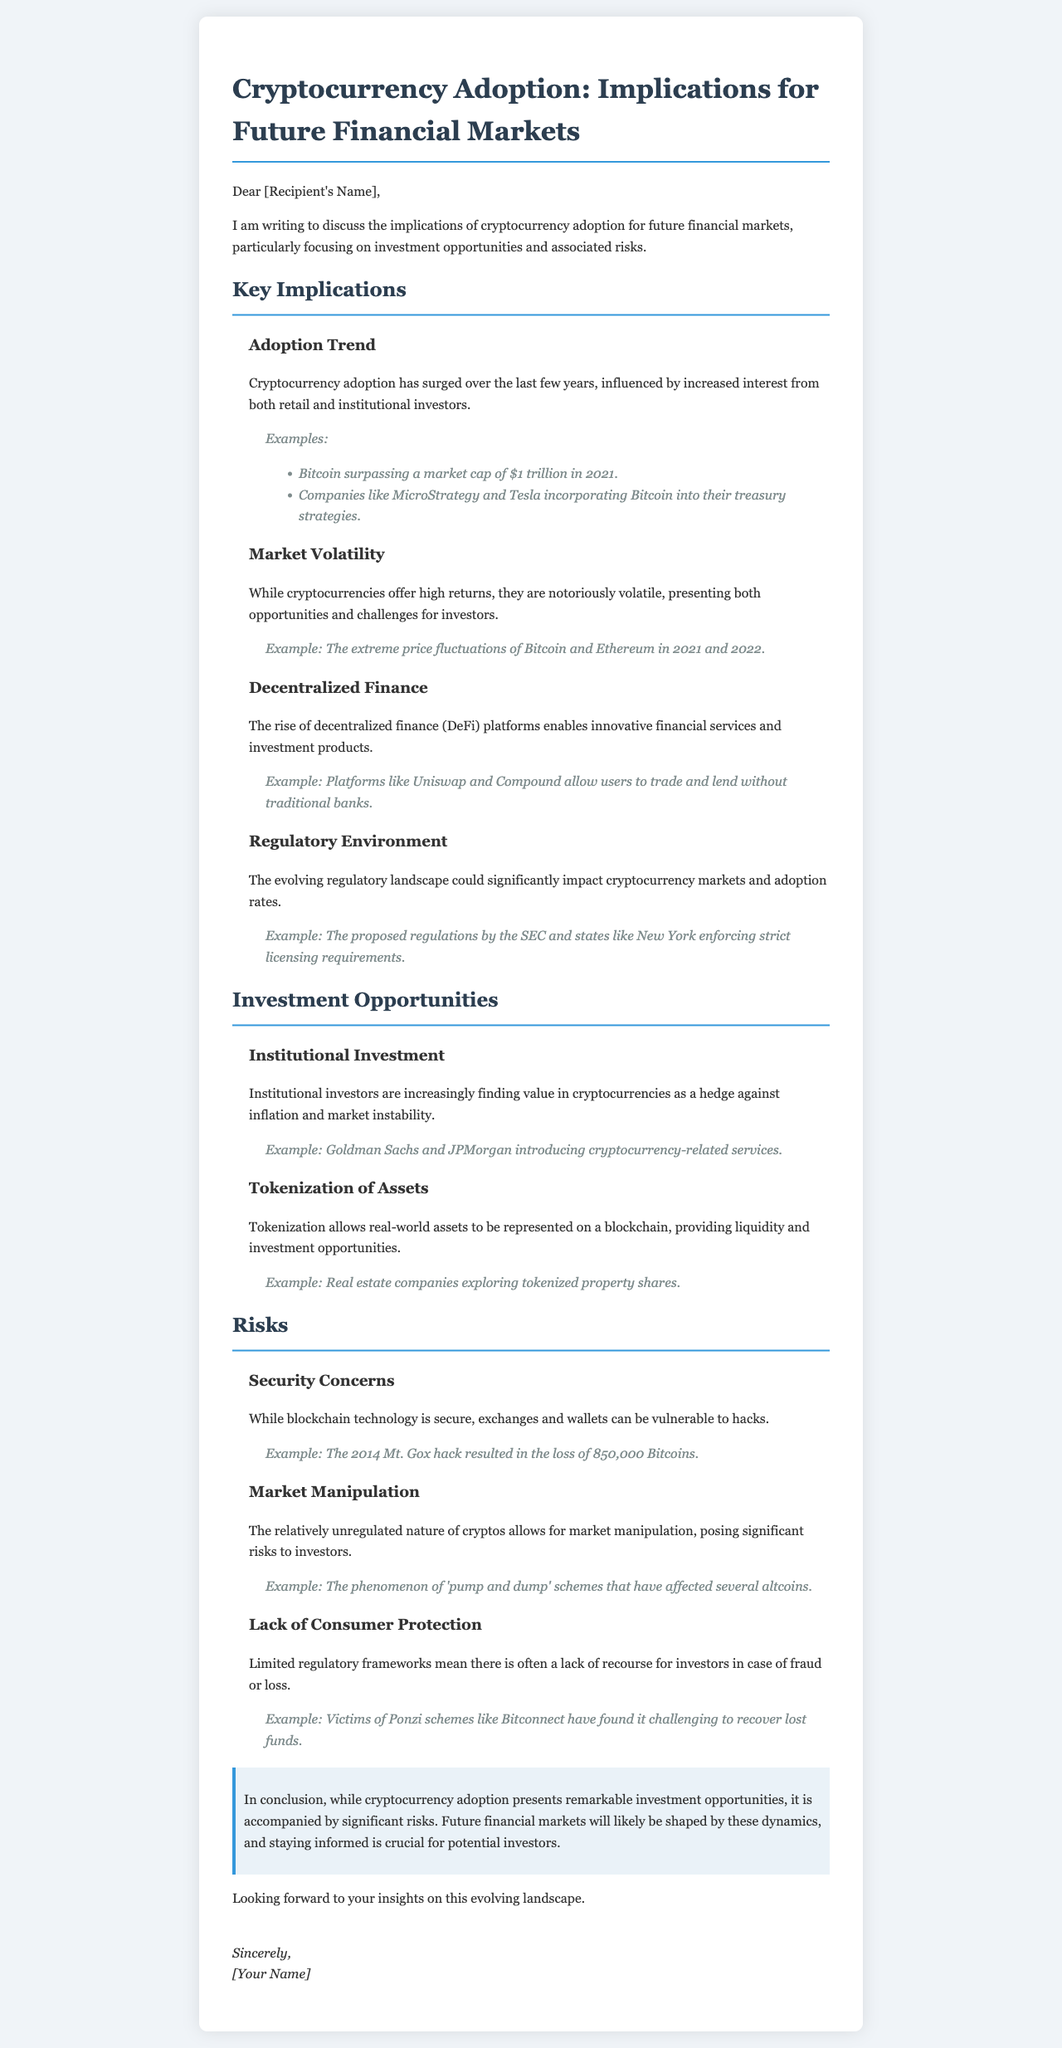What is the main topic of the letter? The main topic of the letter is the implications of cryptocurrency adoption for future financial markets.
Answer: Cryptocurrency Adoption Who surpassed a market cap of $1 trillion in 2021? The document mentions Bitcoin as the cryptocurrency that surpassed a market cap of $1 trillion in 2021.
Answer: Bitcoin Name one decentralized finance platform mentioned. The letter provides examples of decentralized finance platforms, specifically mentioning Uniswap and Compound.
Answer: Uniswap What major concern is associated with cryptocurrency exchanges? The letter highlights security concerns as a significant issue, noting that exchanges and wallets can be vulnerable to hacks.
Answer: Security Concerns Which major banks introduced cryptocurrency-related services? The letter indicates that Goldman Sachs and JPMorgan are examples of banks that introduced cryptocurrency-related services.
Answer: Goldman Sachs and JPMorgan What phenomenon poses risks to investors due to market manipulation? The letter refers to 'pump and dump' schemes as a risk associated with the relatively unregulated nature of cryptocurrencies.
Answer: Pump and dump Who is the letter addressed to? The letter is addressed to [Recipient's Name], indicating a personal note to someone specific.
Answer: [Recipient's Name] What example of tokenization is given in the letter? The letter mentions real estate companies exploring tokenized property shares as an example of tokenization of assets.
Answer: Tokenized property shares What trend has influenced cryptocurrency adoption? The letter states that increased interest from both retail and institutional investors has influenced the trend of cryptocurrency adoption.
Answer: Increased interest What important factor could impact cryptocurrency markets according to the document? The document mentions the evolving regulatory landscape as an important factor that could significantly impact cryptocurrency markets.
Answer: Regulatory Environment 